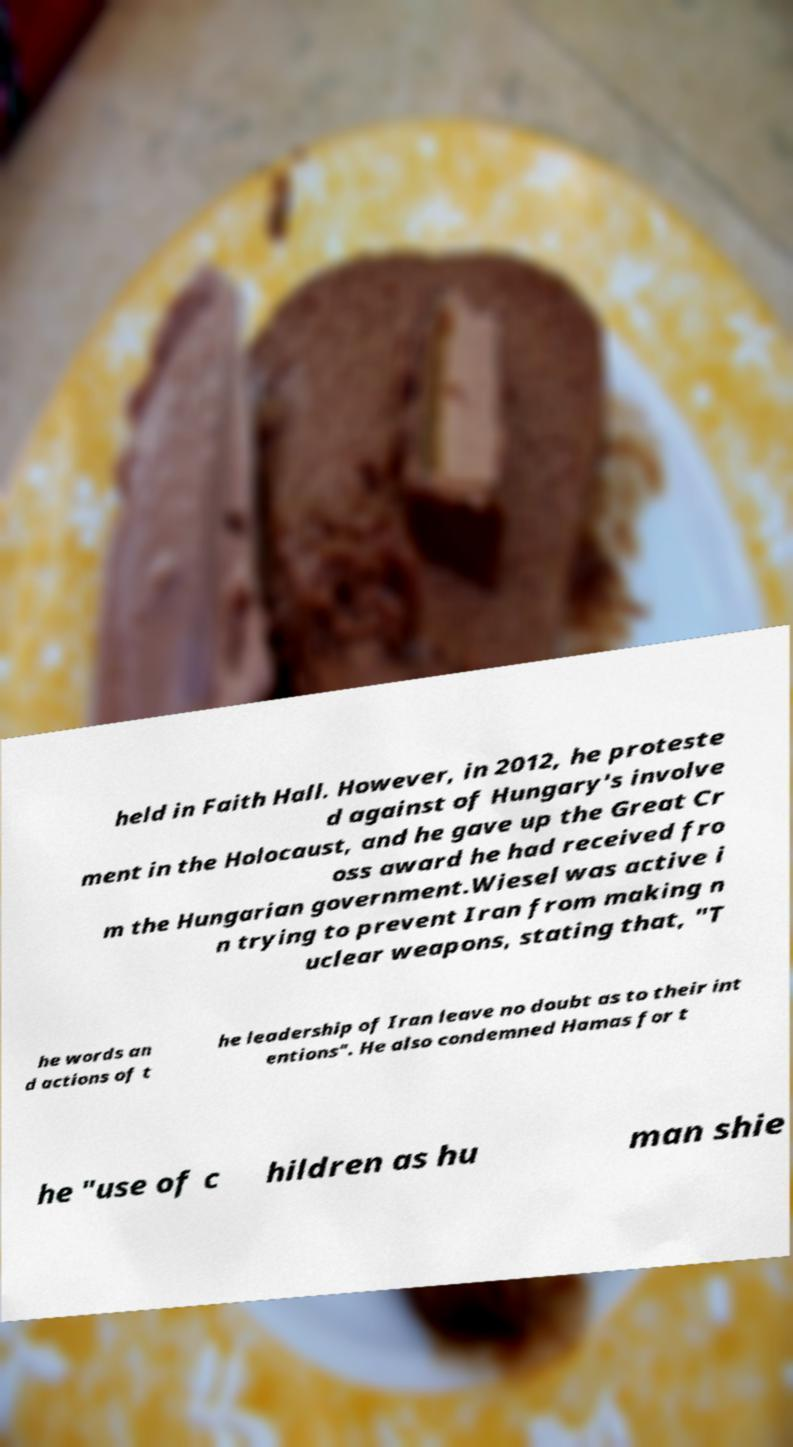Can you read and provide the text displayed in the image?This photo seems to have some interesting text. Can you extract and type it out for me? held in Faith Hall. However, in 2012, he proteste d against of Hungary's involve ment in the Holocaust, and he gave up the Great Cr oss award he had received fro m the Hungarian government.Wiesel was active i n trying to prevent Iran from making n uclear weapons, stating that, "T he words an d actions of t he leadership of Iran leave no doubt as to their int entions". He also condemned Hamas for t he "use of c hildren as hu man shie 